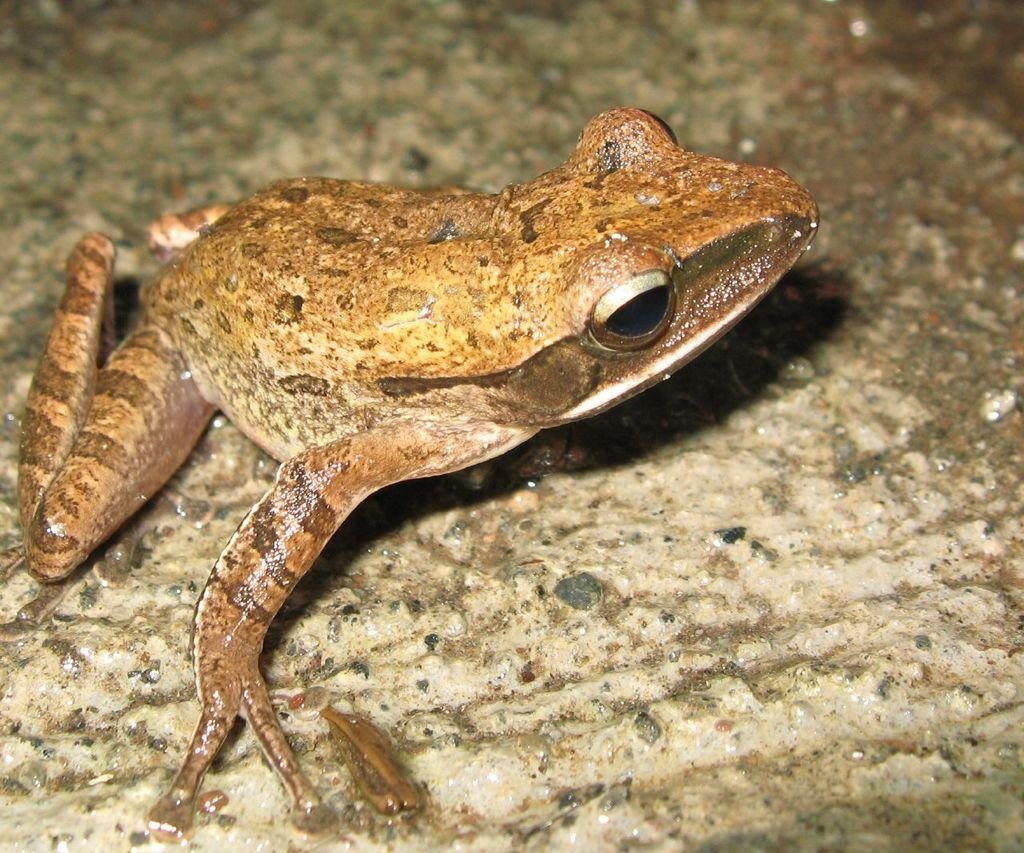What animal is present in the image? There is a frog in the image. What is visible behind the frog? There is water visible behind the frog. What type of lettuce can be seen growing in the market behind the frog? There is no market or lettuce present in the image; it only features a frog and water. 